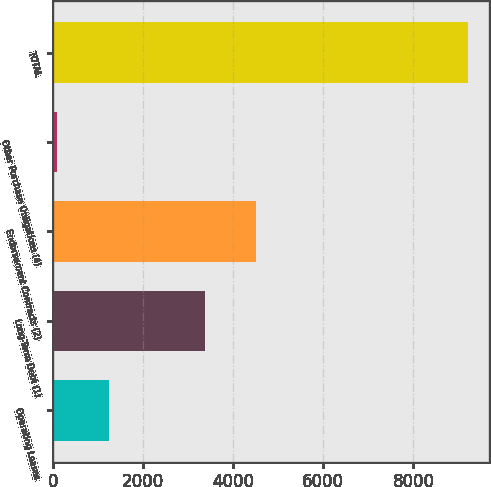Convert chart. <chart><loc_0><loc_0><loc_500><loc_500><bar_chart><fcel>Operating Leases<fcel>Long-Term Debt (1)<fcel>Endorsement Contracts (2)<fcel>Other Purchase Obligations (4)<fcel>TOTAL<nl><fcel>1244<fcel>3365<fcel>4514<fcel>90<fcel>9213<nl></chart> 